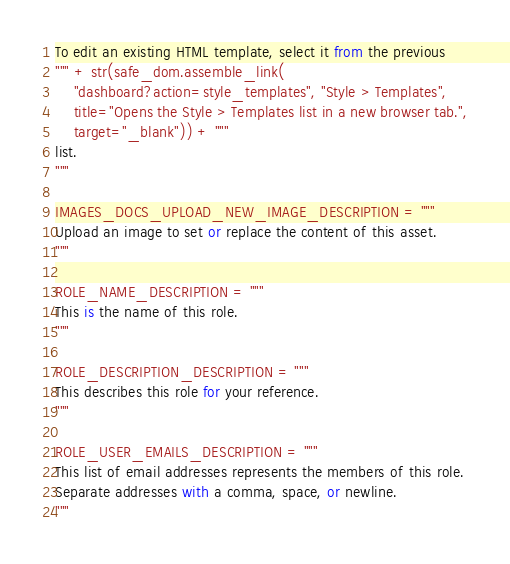<code> <loc_0><loc_0><loc_500><loc_500><_Python_>To edit an existing HTML template, select it from the previous
""" + str(safe_dom.assemble_link(
    "dashboard?action=style_templates", "Style > Templates",
    title="Opens the Style > Templates list in a new browser tab.",
    target="_blank")) + """
list.
"""

IMAGES_DOCS_UPLOAD_NEW_IMAGE_DESCRIPTION = """
Upload an image to set or replace the content of this asset.
"""

ROLE_NAME_DESCRIPTION = """
This is the name of this role.
"""

ROLE_DESCRIPTION_DESCRIPTION = """
This describes this role for your reference.
"""

ROLE_USER_EMAILS_DESCRIPTION = """
This list of email addresses represents the members of this role.
Separate addresses with a comma, space, or newline.
"""
</code> 